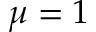<formula> <loc_0><loc_0><loc_500><loc_500>\mu = 1</formula> 